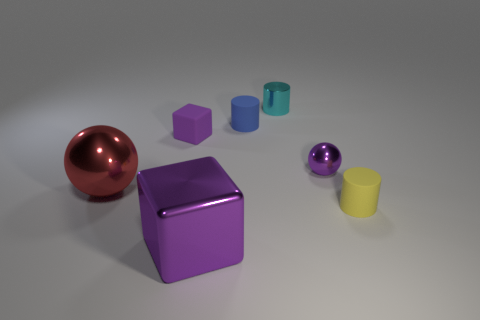Add 1 balls. How many objects exist? 8 Subtract all spheres. How many objects are left? 5 Subtract 0 gray blocks. How many objects are left? 7 Subtract all cubes. Subtract all small purple metal cylinders. How many objects are left? 5 Add 6 balls. How many balls are left? 8 Add 2 small gray metal blocks. How many small gray metal blocks exist? 2 